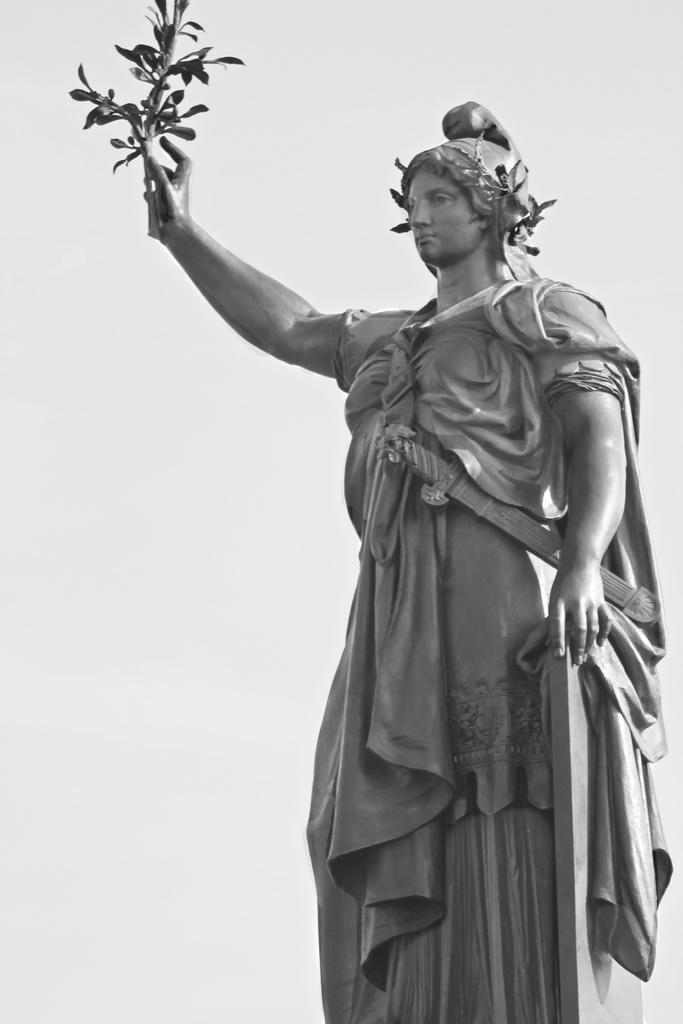Can you describe this image briefly? In this picture we can see a statue of a person holding a plant with hand and in the background we can see white color. 